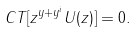Convert formula to latex. <formula><loc_0><loc_0><loc_500><loc_500>C T [ z ^ { y + y ^ { i } } U ( z ) ] = 0 .</formula> 